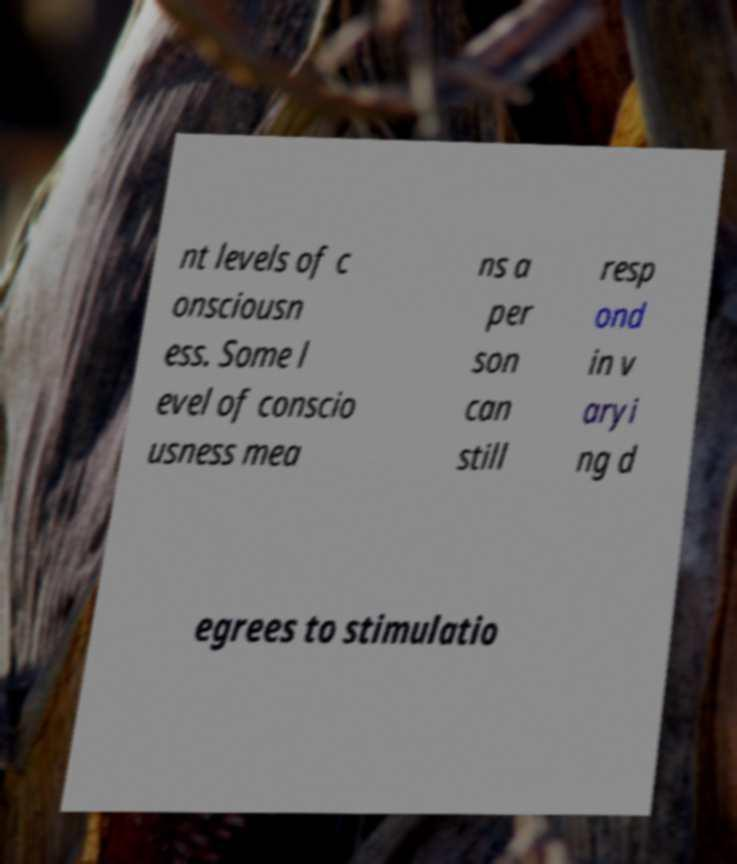For documentation purposes, I need the text within this image transcribed. Could you provide that? nt levels of c onsciousn ess. Some l evel of conscio usness mea ns a per son can still resp ond in v aryi ng d egrees to stimulatio 